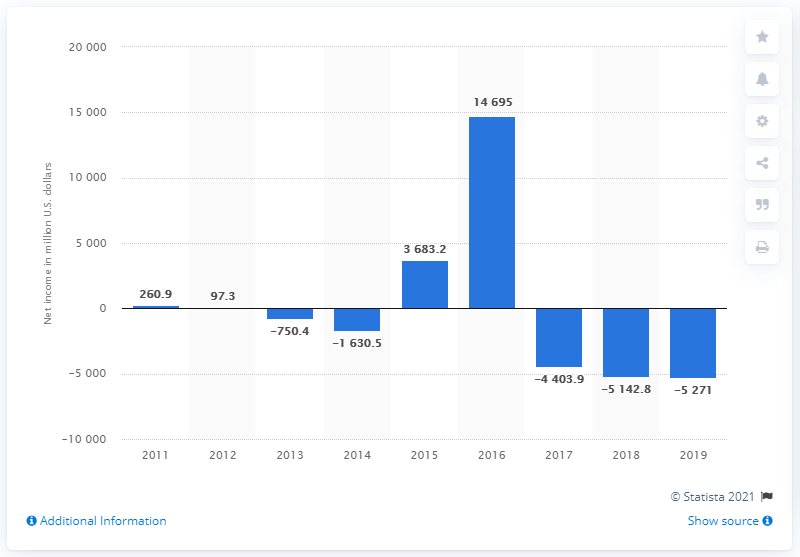Point out several critical features in this image. In the year 2016, Allergan's net income reached its peak. 